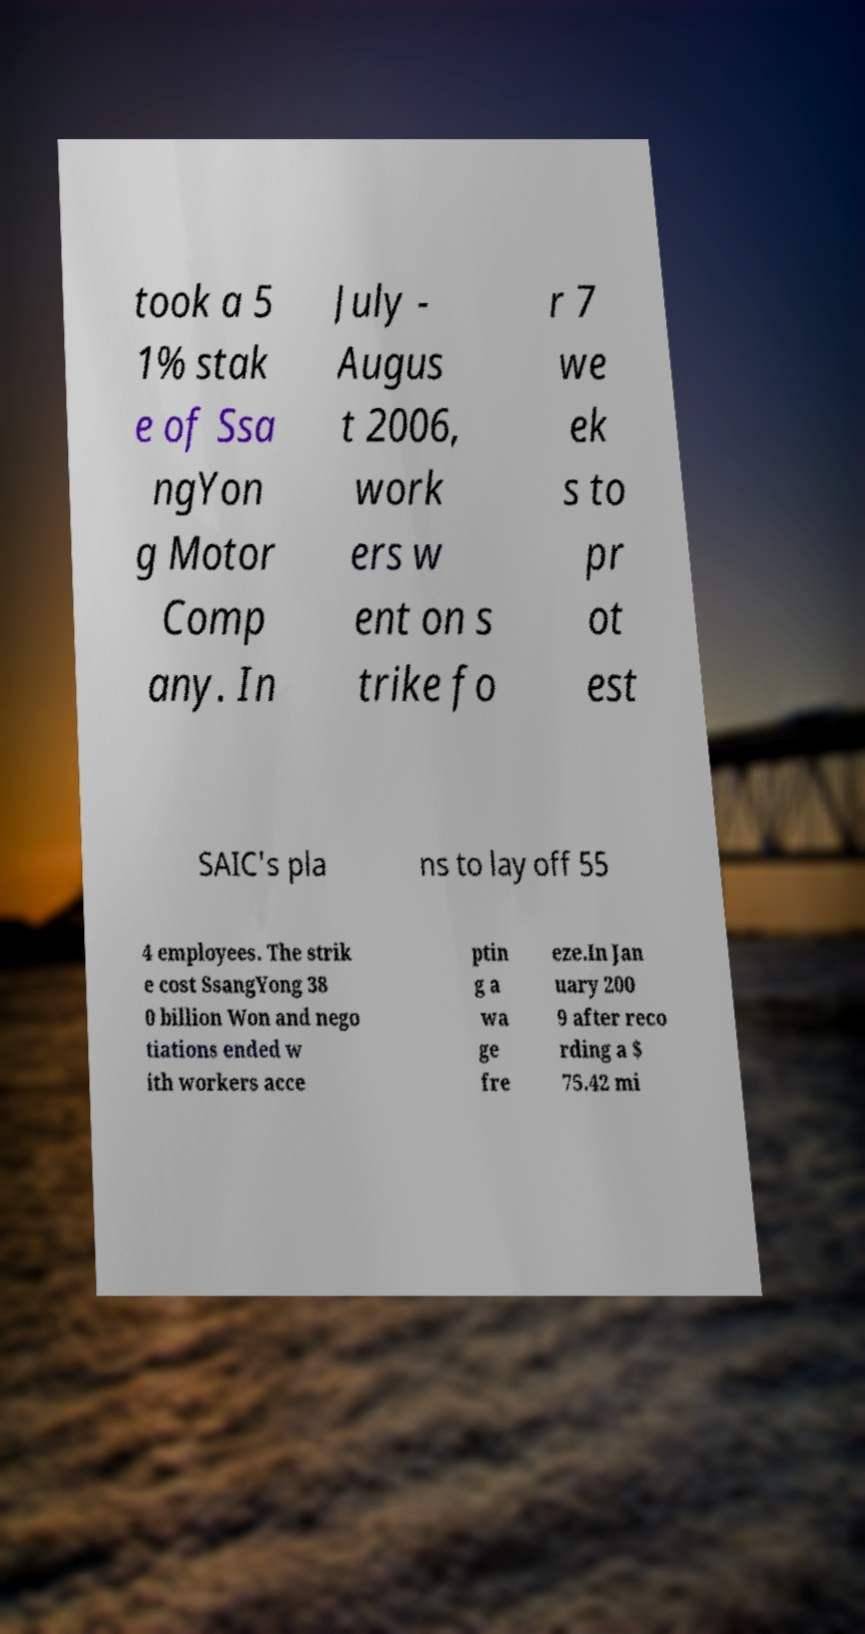Can you read and provide the text displayed in the image?This photo seems to have some interesting text. Can you extract and type it out for me? took a 5 1% stak e of Ssa ngYon g Motor Comp any. In July - Augus t 2006, work ers w ent on s trike fo r 7 we ek s to pr ot est SAIC's pla ns to lay off 55 4 employees. The strik e cost SsangYong 38 0 billion Won and nego tiations ended w ith workers acce ptin g a wa ge fre eze.In Jan uary 200 9 after reco rding a $ 75.42 mi 